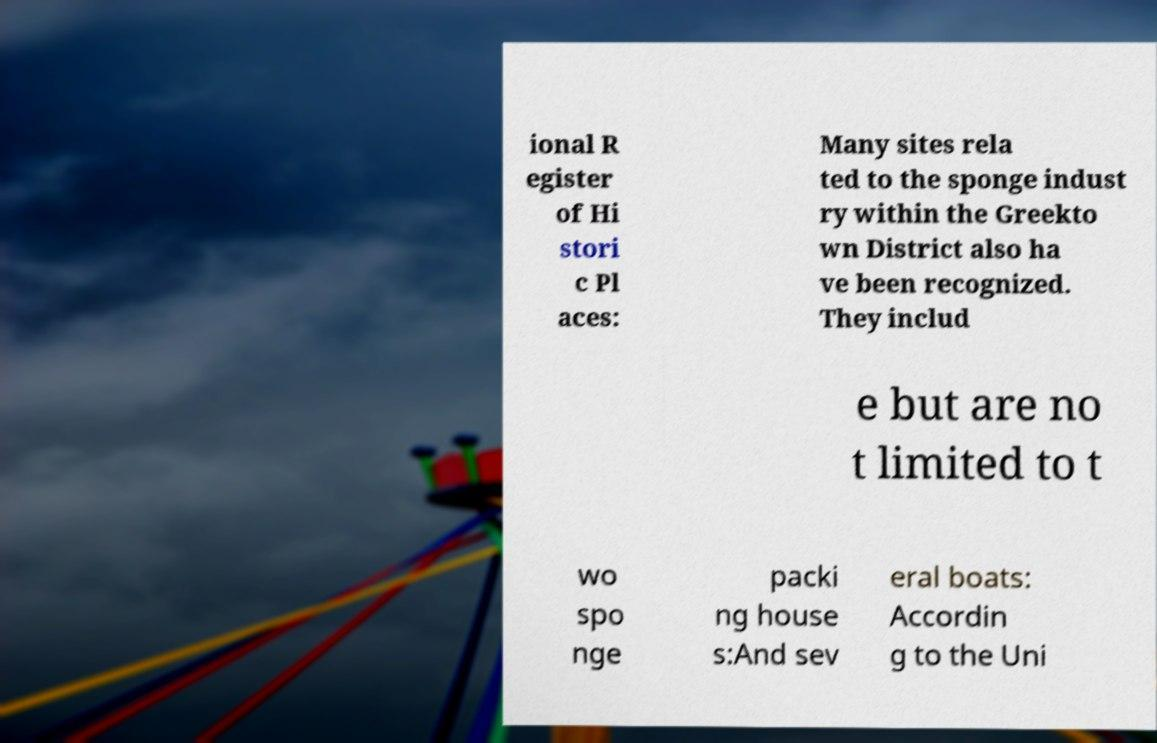Could you extract and type out the text from this image? ional R egister of Hi stori c Pl aces: Many sites rela ted to the sponge indust ry within the Greekto wn District also ha ve been recognized. They includ e but are no t limited to t wo spo nge packi ng house s:And sev eral boats: Accordin g to the Uni 